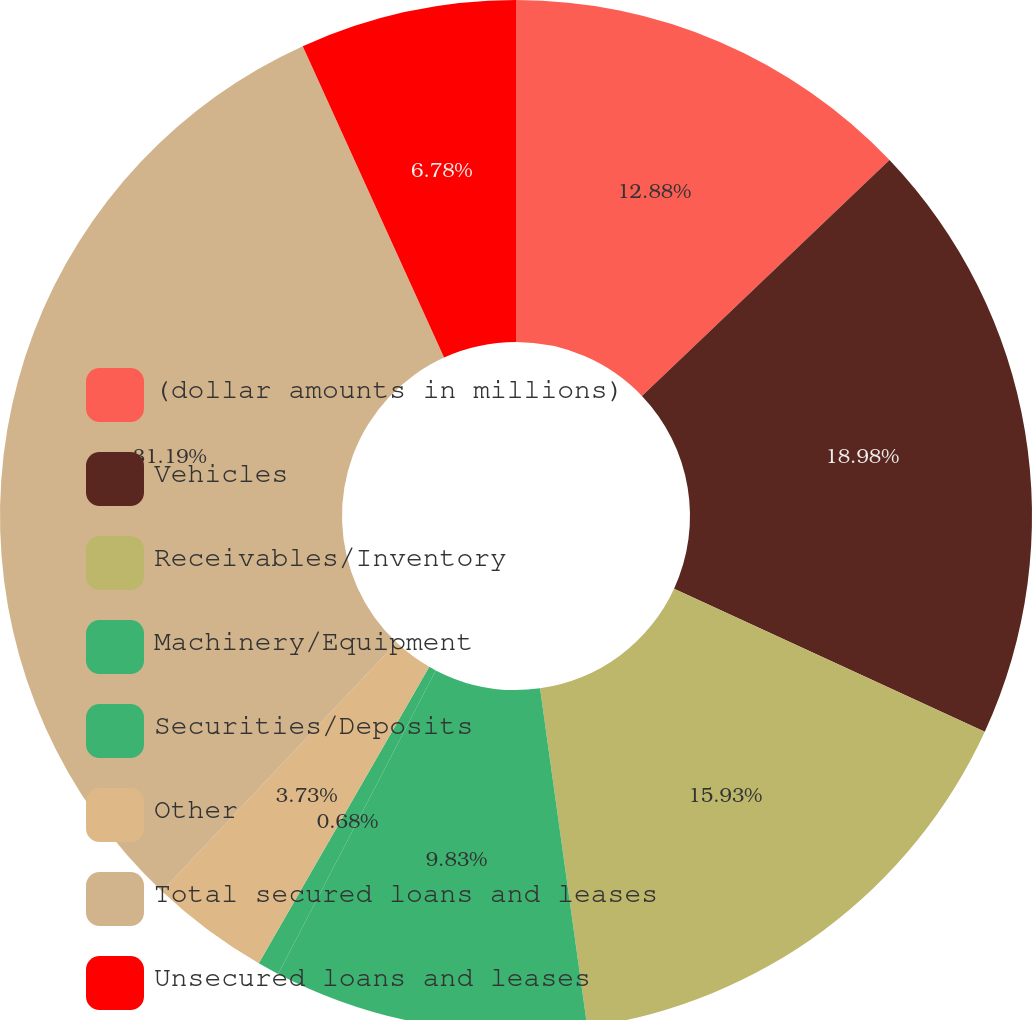<chart> <loc_0><loc_0><loc_500><loc_500><pie_chart><fcel>(dollar amounts in millions)<fcel>Vehicles<fcel>Receivables/Inventory<fcel>Machinery/Equipment<fcel>Securities/Deposits<fcel>Other<fcel>Total secured loans and leases<fcel>Unsecured loans and leases<nl><fcel>12.88%<fcel>18.98%<fcel>15.93%<fcel>9.83%<fcel>0.68%<fcel>3.73%<fcel>31.18%<fcel>6.78%<nl></chart> 